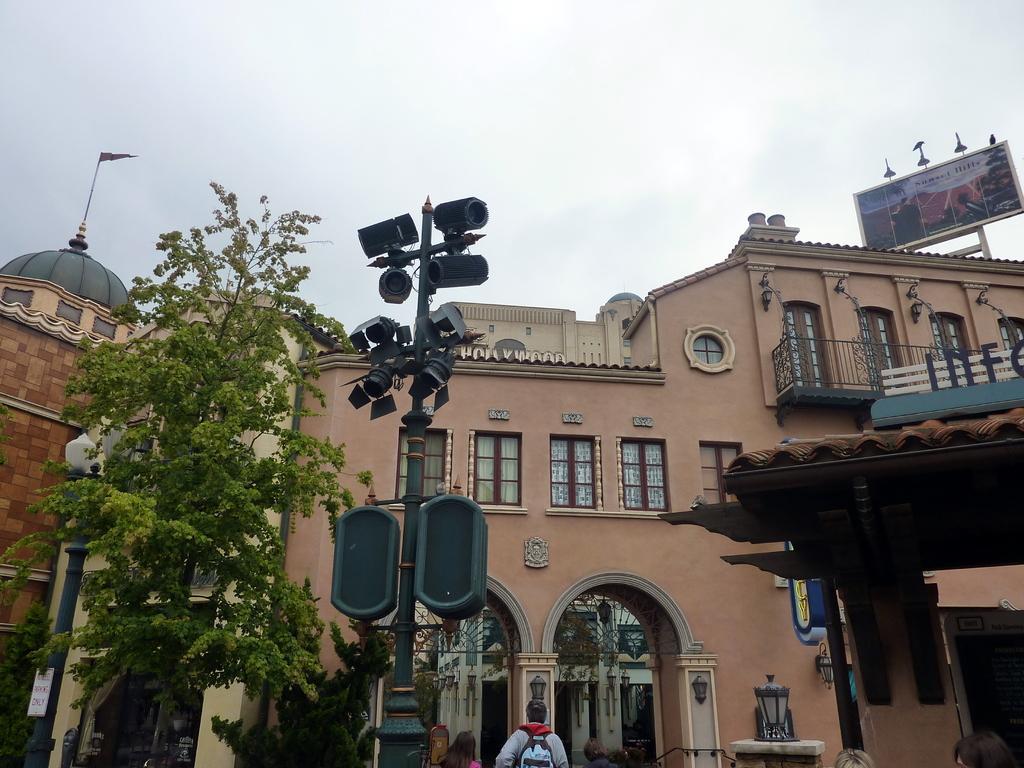Describe this image in one or two sentences. In this image at front there are trees, traffic signal and at the back side there are buildings. In front of the building there are few people standing on the road. At the background there is sky. 